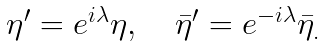<formula> <loc_0><loc_0><loc_500><loc_500>\begin{array} { c } \eta ^ { \prime } = e ^ { i \lambda } \eta , \quad \bar { \eta } ^ { \prime } = e ^ { - i \lambda } \bar { \eta } _ { . } \end{array}</formula> 